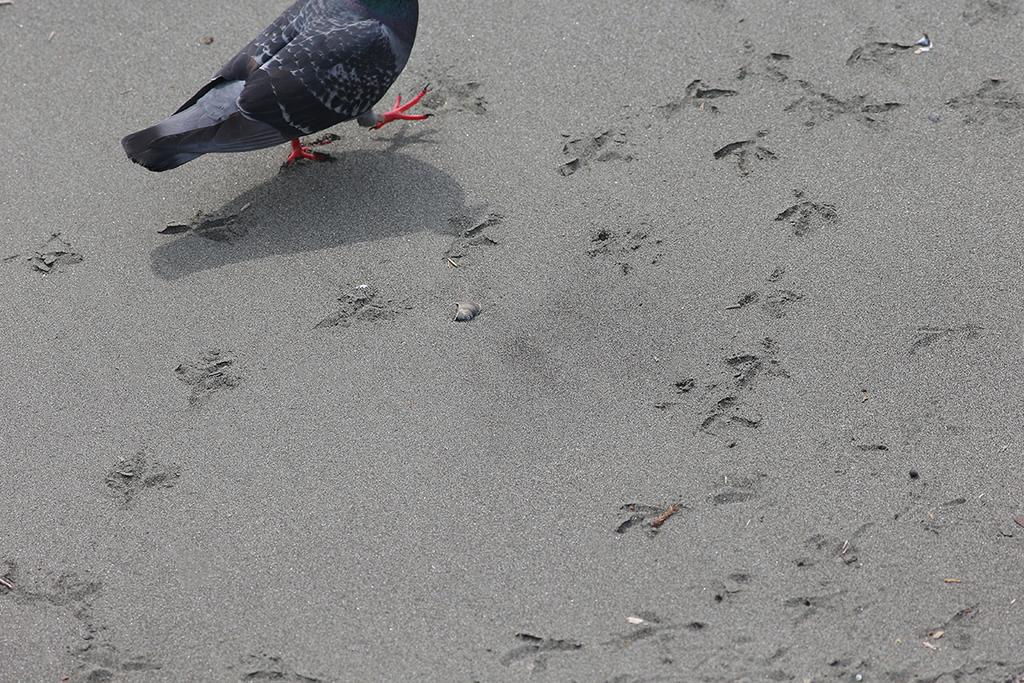What type of animal can be seen in the image? There is a bird in the image. What is the bird doing in the image? The bird is walking. What evidence is there of the bird's movement in the image? There are foot marks on the ground in the image. What word is the bird saying in the image? Birds do not have the ability to speak or say words, so there is no word being said by the bird in the image. 